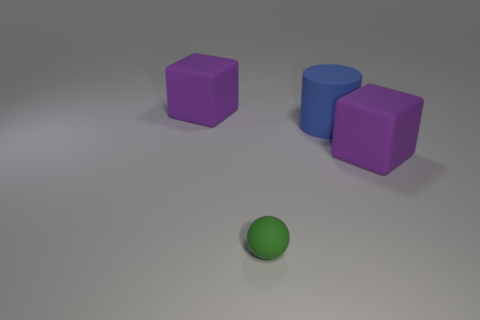Is the big purple thing on the left side of the small green rubber sphere made of the same material as the large object that is on the right side of the big cylinder?
Your answer should be very brief. Yes. The big purple object behind the large purple cube that is right of the tiny thing is what shape?
Give a very brief answer. Cube. Are there any other things that have the same color as the matte cylinder?
Provide a succinct answer. No. There is a thing in front of the big object on the right side of the large blue cylinder; are there any large cylinders that are on the left side of it?
Provide a short and direct response. No. Is the color of the large rubber object that is on the left side of the small green thing the same as the big object in front of the cylinder?
Ensure brevity in your answer.  Yes. What size is the cube that is behind the blue cylinder right of the big purple object that is on the left side of the big rubber cylinder?
Provide a succinct answer. Large. How many other objects are there of the same material as the tiny green thing?
Provide a short and direct response. 3. There is a rubber cube on the left side of the rubber ball; how big is it?
Keep it short and to the point. Large. What number of purple cubes are both in front of the cylinder and left of the blue thing?
Your answer should be compact. 0. Are any blue rubber balls visible?
Make the answer very short. No. 